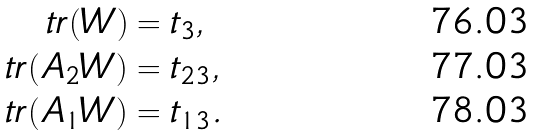Convert formula to latex. <formula><loc_0><loc_0><loc_500><loc_500>\ t r ( W ) & = t _ { 3 } , \\ \ t r ( A _ { 2 } W ) & = t _ { 2 3 } , \\ \ t r ( A _ { 1 } W ) & = t _ { 1 3 } .</formula> 